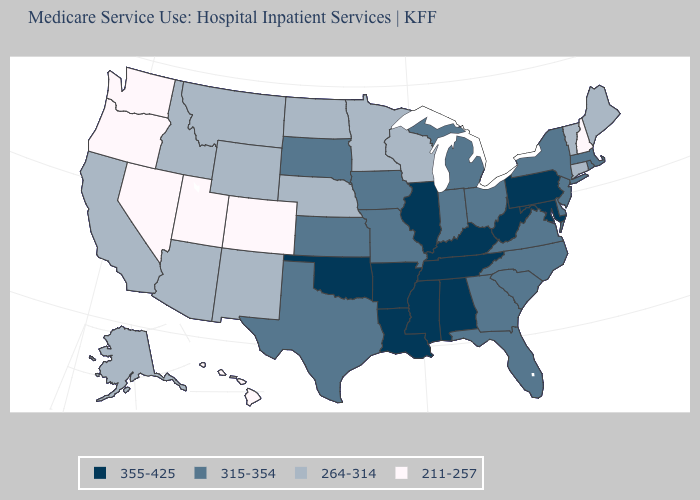What is the lowest value in the MidWest?
Write a very short answer. 264-314. Name the states that have a value in the range 315-354?
Write a very short answer. Delaware, Florida, Georgia, Indiana, Iowa, Kansas, Massachusetts, Michigan, Missouri, New Jersey, New York, North Carolina, Ohio, Rhode Island, South Carolina, South Dakota, Texas, Virginia. Which states hav the highest value in the West?
Short answer required. Alaska, Arizona, California, Idaho, Montana, New Mexico, Wyoming. What is the value of Wyoming?
Short answer required. 264-314. Does Illinois have the lowest value in the MidWest?
Short answer required. No. Does New Hampshire have the lowest value in the Northeast?
Write a very short answer. Yes. What is the highest value in the USA?
Quick response, please. 355-425. Does New Hampshire have the same value as Minnesota?
Be succinct. No. Which states hav the highest value in the West?
Answer briefly. Alaska, Arizona, California, Idaho, Montana, New Mexico, Wyoming. What is the highest value in states that border Maryland?
Concise answer only. 355-425. Name the states that have a value in the range 264-314?
Be succinct. Alaska, Arizona, California, Connecticut, Idaho, Maine, Minnesota, Montana, Nebraska, New Mexico, North Dakota, Vermont, Wisconsin, Wyoming. Which states have the highest value in the USA?
Be succinct. Alabama, Arkansas, Illinois, Kentucky, Louisiana, Maryland, Mississippi, Oklahoma, Pennsylvania, Tennessee, West Virginia. What is the value of Nevada?
Keep it brief. 211-257. What is the highest value in the MidWest ?
Short answer required. 355-425. What is the value of Arkansas?
Answer briefly. 355-425. 